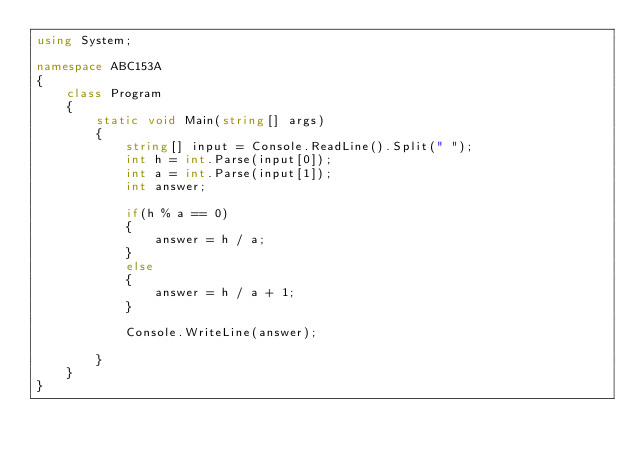Convert code to text. <code><loc_0><loc_0><loc_500><loc_500><_C#_>using System;

namespace ABC153A
{
    class Program
    {
        static void Main(string[] args)
        {
            string[] input = Console.ReadLine().Split(" ");
            int h = int.Parse(input[0]);
            int a = int.Parse(input[1]);
            int answer;

            if(h % a == 0)
            {
                answer = h / a;
            }
            else
            {
                answer = h / a + 1;
            }

            Console.WriteLine(answer);

        }
    }
}
</code> 